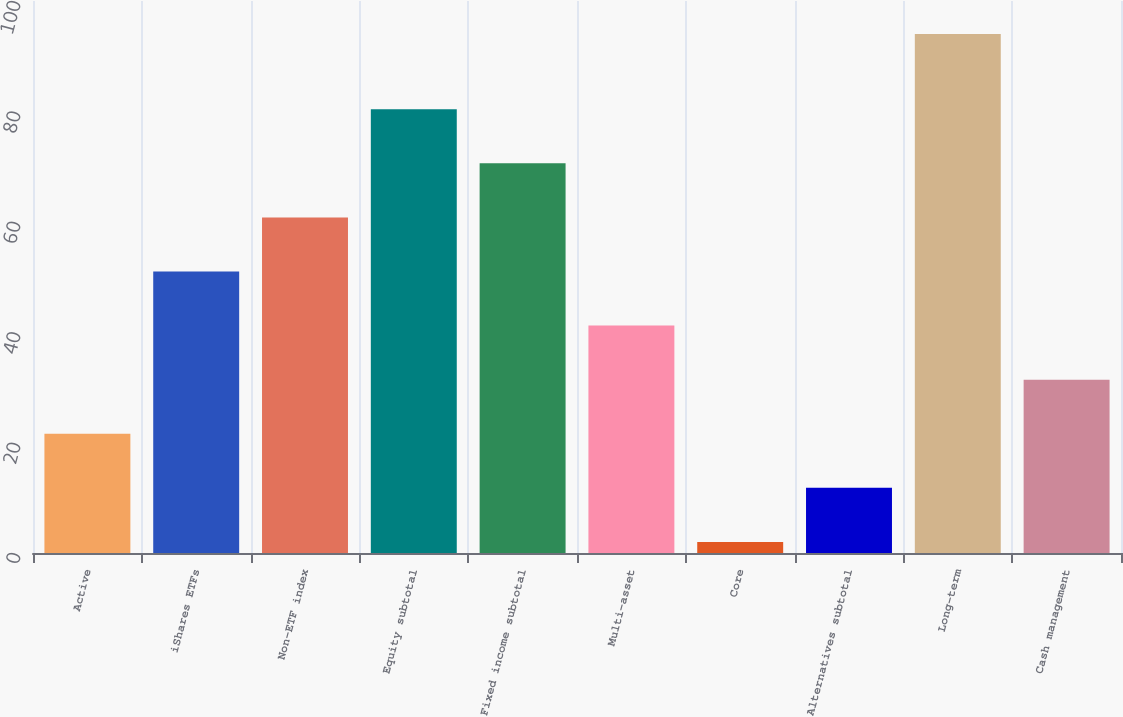<chart> <loc_0><loc_0><loc_500><loc_500><bar_chart><fcel>Active<fcel>iShares ETFs<fcel>Non-ETF index<fcel>Equity subtotal<fcel>Fixed income subtotal<fcel>Multi-asset<fcel>Core<fcel>Alternatives subtotal<fcel>Long-term<fcel>Cash management<nl><fcel>21.6<fcel>51<fcel>60.8<fcel>80.4<fcel>70.6<fcel>41.2<fcel>2<fcel>11.8<fcel>94<fcel>31.4<nl></chart> 